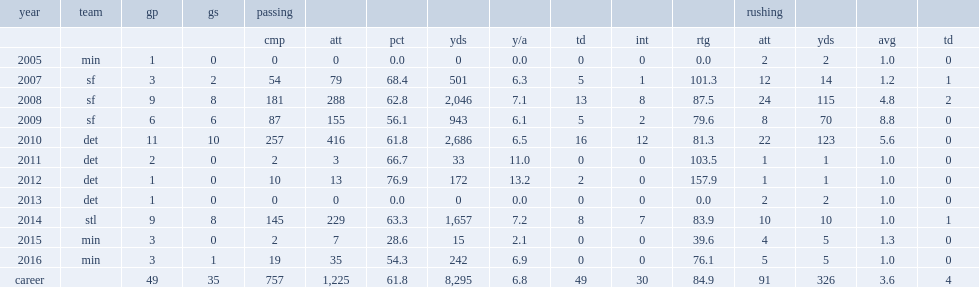How many passing yards did hill finish the 2014 season with? 1657.0. How many rushing yards did shaun hill get in 2010? 123.0. 